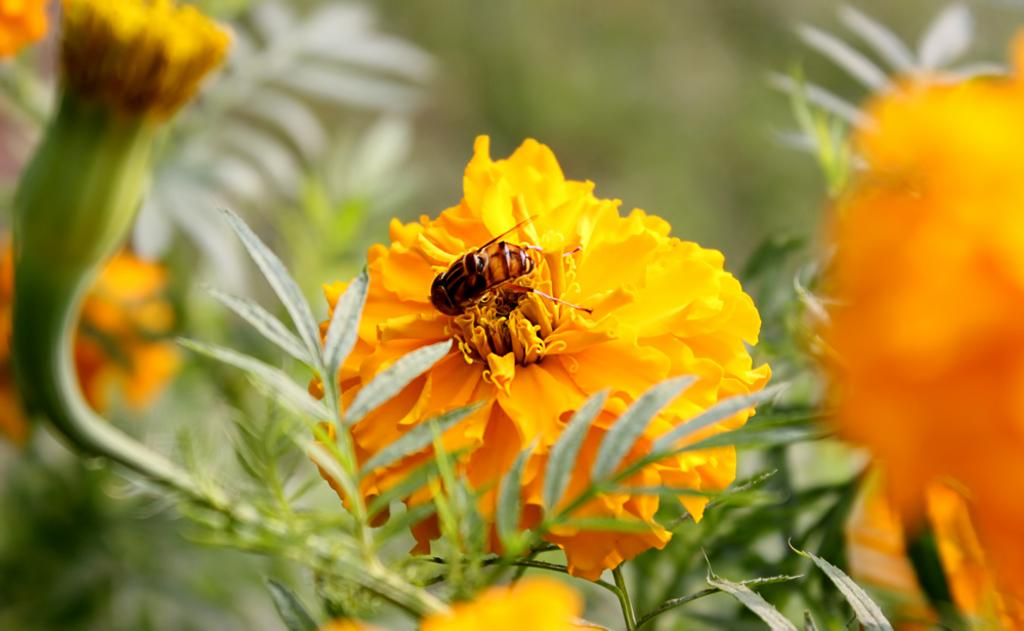What is on the flower in the image? There is an insect on a flower in the image. What type of living organisms can be seen in the image? Insects and flowers are visible in the image. What else can be seen in the image besides the insect and flower? There are plants in the image. How would you describe the background of the image? The background of the image is blurred. What is the rate of the organization's growth in the image? There is no mention of an organization or growth rate in the image; it features an insect on a flower with plants and a blurred background. 